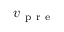Convert formula to latex. <formula><loc_0><loc_0><loc_500><loc_500>v _ { p r e }</formula> 